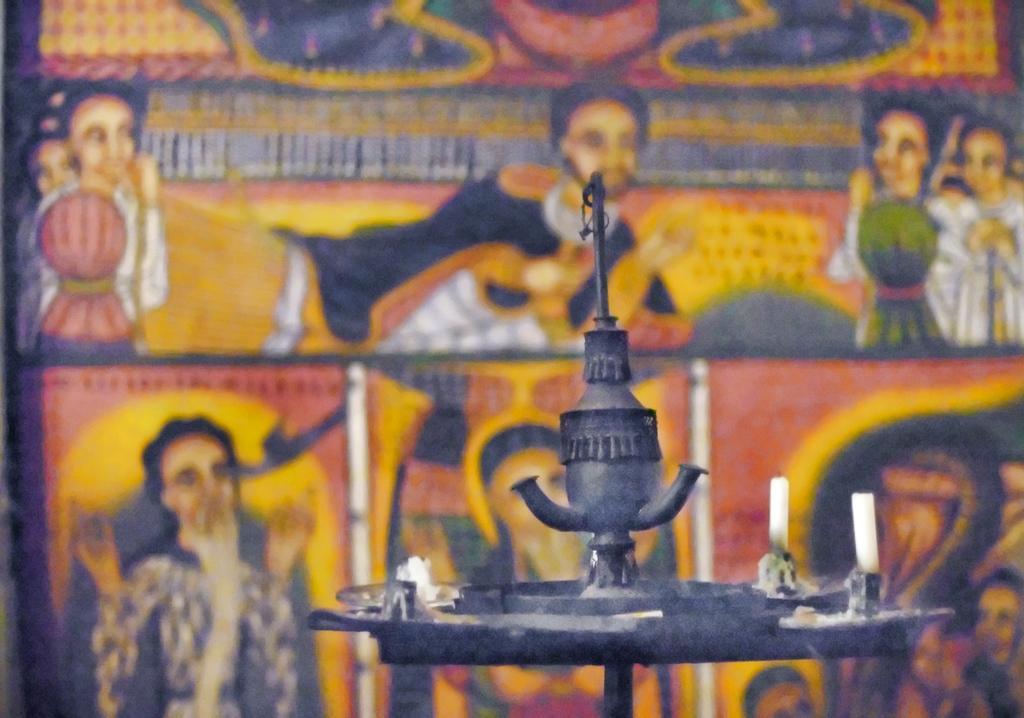In one or two sentences, can you explain what this image depicts? In front of the picture, we see a candle holder on which the candles are placed. Behind that, we see a carpet or a wall painting. It is in yellow, blue and pink color. We see the painting of men on the wall. 